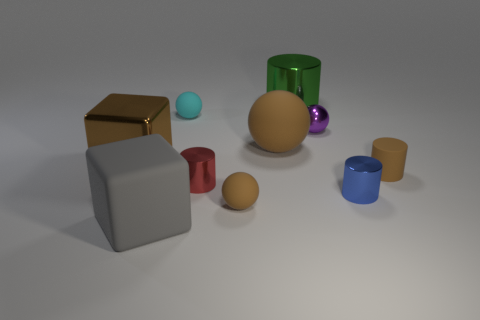Subtract all cylinders. How many objects are left? 6 Add 9 big green cylinders. How many big green cylinders exist? 10 Subtract 0 cyan cylinders. How many objects are left? 10 Subtract all tiny brown cylinders. Subtract all small purple objects. How many objects are left? 8 Add 4 large brown spheres. How many large brown spheres are left? 5 